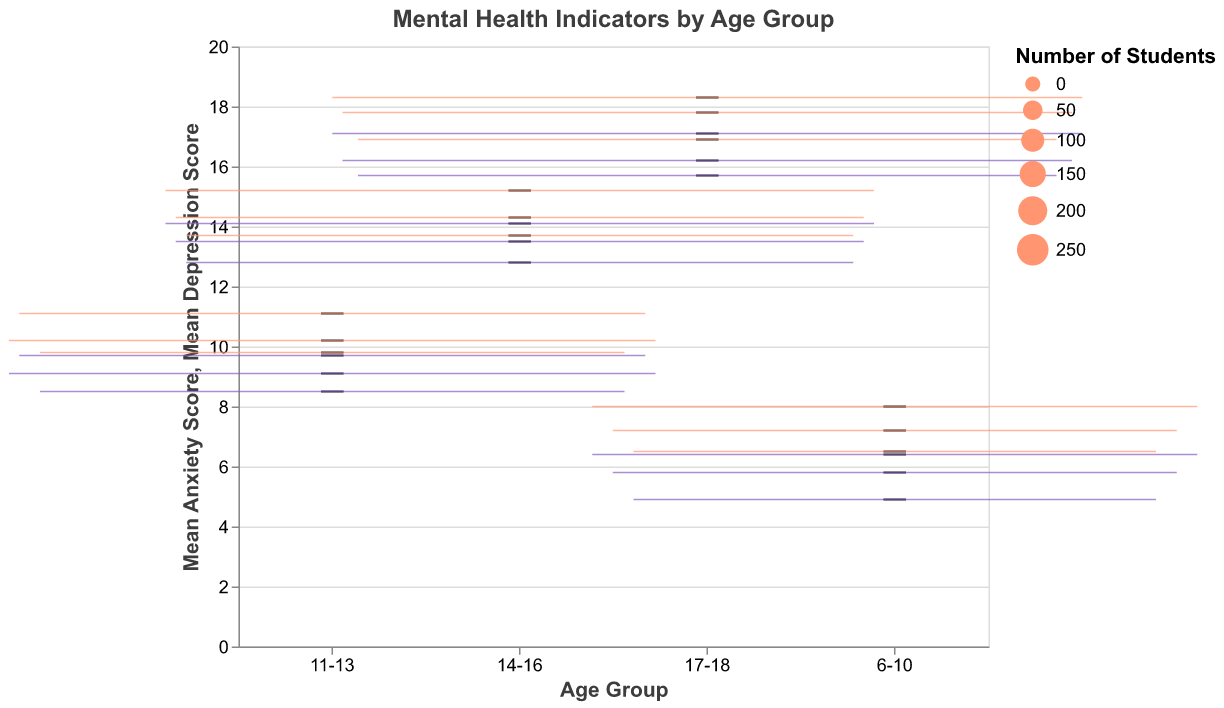What is the title of the figure? The title of the figure is usually displayed prominently at the top and is intended to give a quick understanding of what the figure represents. Here, the title is "Mental Health Indicators by Age Group."
Answer: Mental Health Indicators by Age Group What are the two metrics shown on the y-axes? The y-axes of the figure show two different mental health indicators. One y-axis shows "Mean Anxiety Score" and the other y-axis shows "Mean Depression Score."
Answer: Mean Anxiety Score, Mean Depression Score How does the proportion of students receiving counseling support change as the age group increases? From the data provided, as the age group increases from 6-10 to 17-18, the proportion of students receiving counseling support increases. This is evident from the listed proportions for each age group.
Answer: Increases Which age group has the highest median anxiety score? To determine the highest median anxiety score, one needs to look at the median lines within the box plots for each age group. The age group 17-18 has the highest median anxiety score.
Answer: 17-18 Which age group has the lowest mean depression score and what is that score? To find the lowest mean depression score, look at the box plot for "Mean Depression Score" and identify the lowest point. The age group 6-10 has the lowest mean depression score of 4.9.
Answer: 6-10, 4.9 Compare the median anxiety scores of the 11-13 and 14-16 age groups. Which is higher? To compare, we need to look at the median lines within their respective box plots. The median anxiety score for 14-16 appears to be higher than for 11-13.
Answer: 14-16 What is the range (min to max) of mean anxiety scores for the age group 14-16? The range of mean anxiety scores is identified by the lowest and highest points in the box plot for the 14-16 age group. The minimum is 13.7, and the maximum is 15.2, so the range is 13.7 to 15.2.
Answer: 13.7 to 15.2 Which age group shows the highest variability in mean depression scores? Variability can be inferred from the length of the box in the box plots. The age group with the largest spread (distance from min to max) in mean depression scores is the 17-18 age group.
Answer: 17-18 What's the median mean depression score for the age group 11-13? The median is represented by the line inside the box plot for the "Mean Depression Score" of the 11-13 age group. Observing the figure, the median value appears to be around 9.1.
Answer: 9.1 